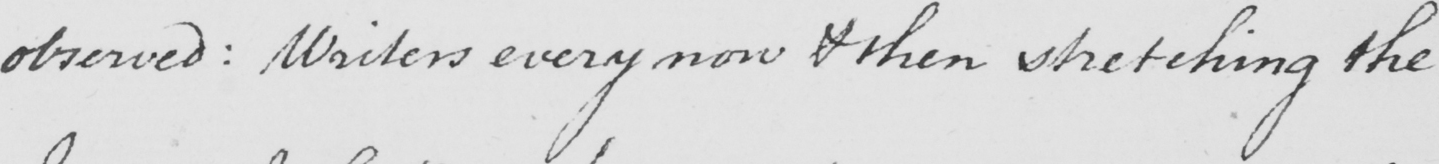What is written in this line of handwriting? observed :  Writers every now & then stretching the 